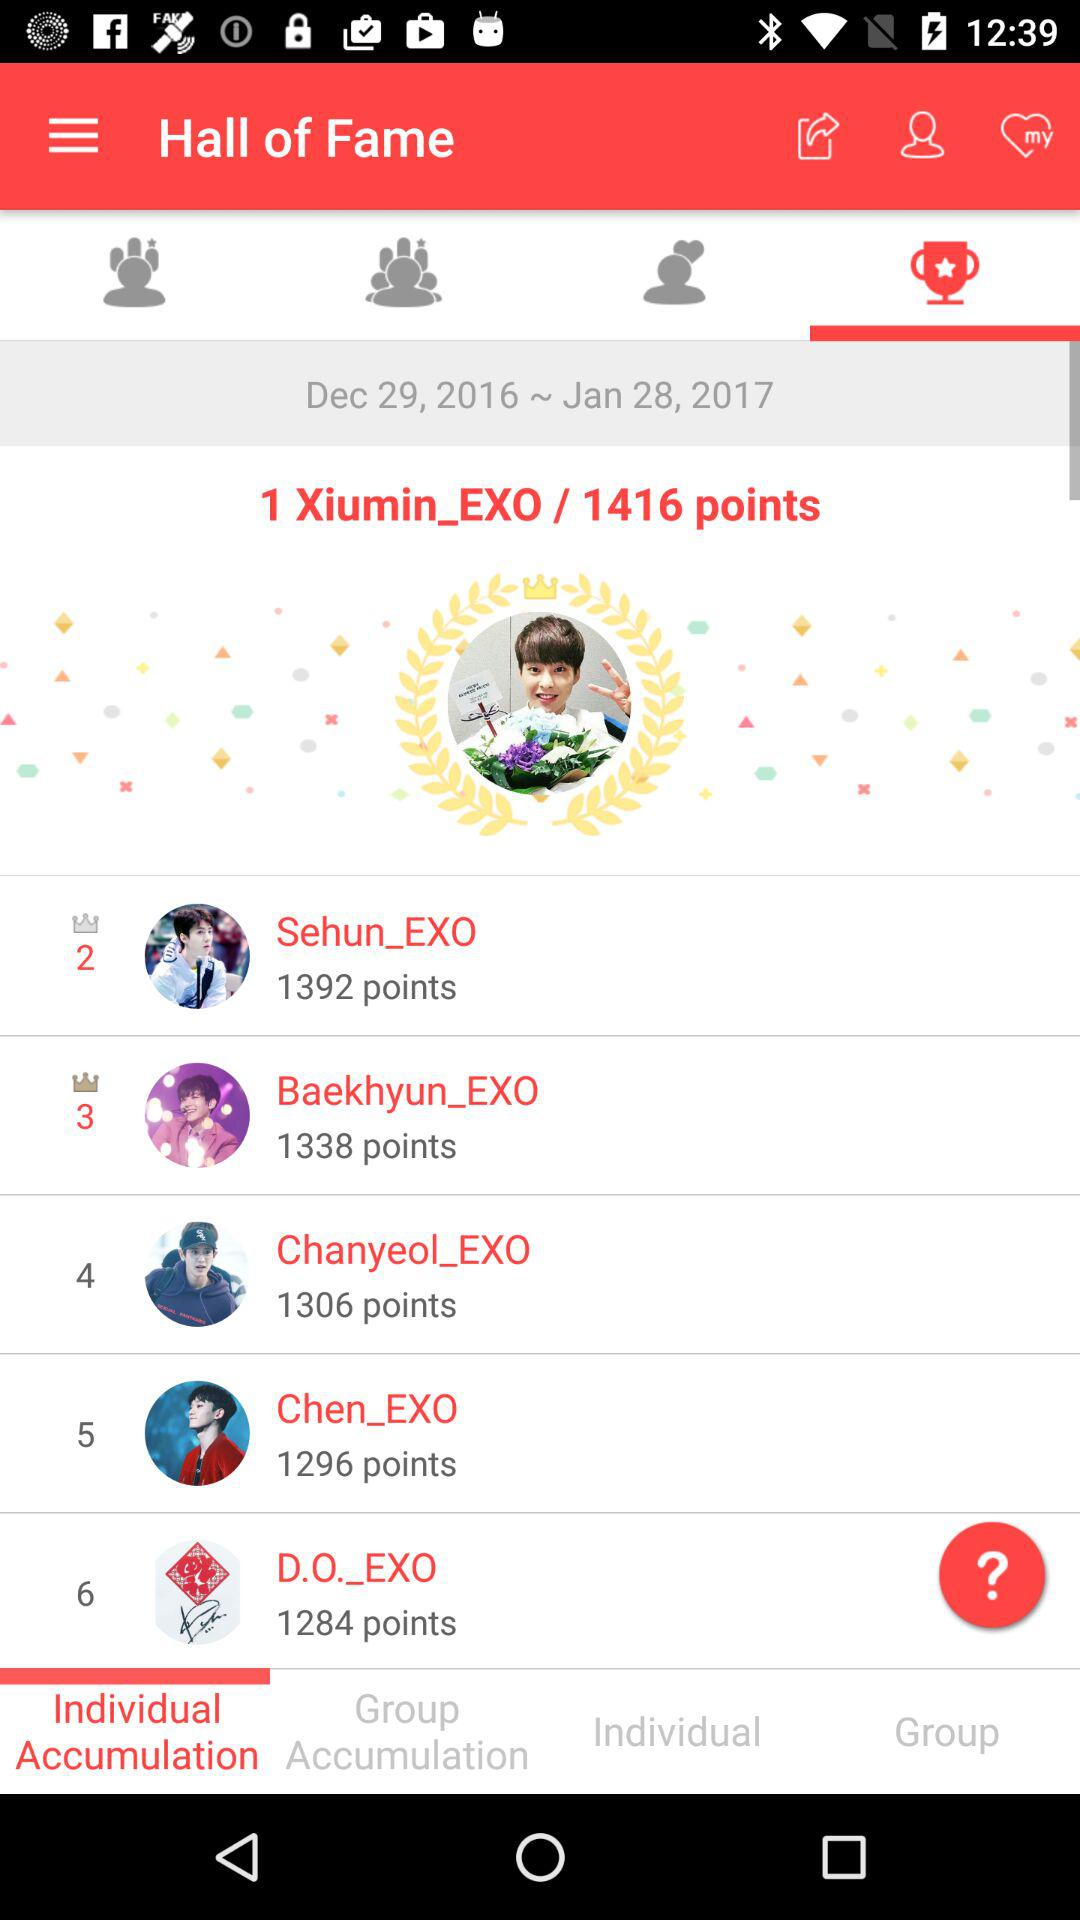What is the date range? The date range is December 29, 2016 to January 28, 2017. 